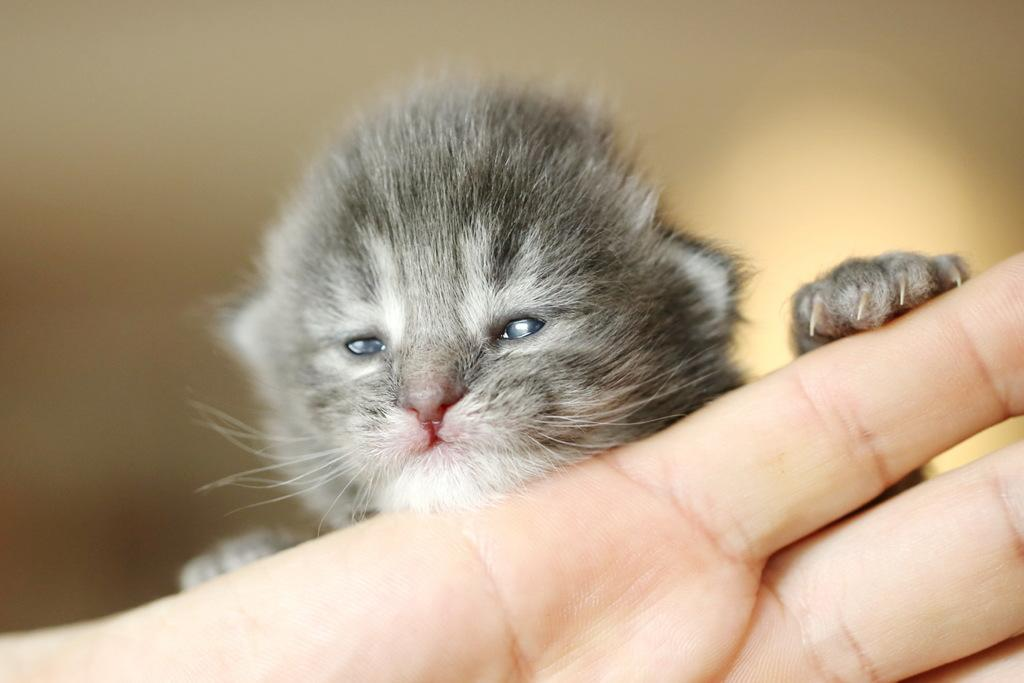What part of a person can be seen in the image? There is a person's hand in the image. What type of animal is present in the image? There is a cat in the image. Can you describe the background of the image? The background of the image is blurred. What type of button is the cat pressing in the image? There is no button present in the image, and the cat is not shown interacting with any objects. 